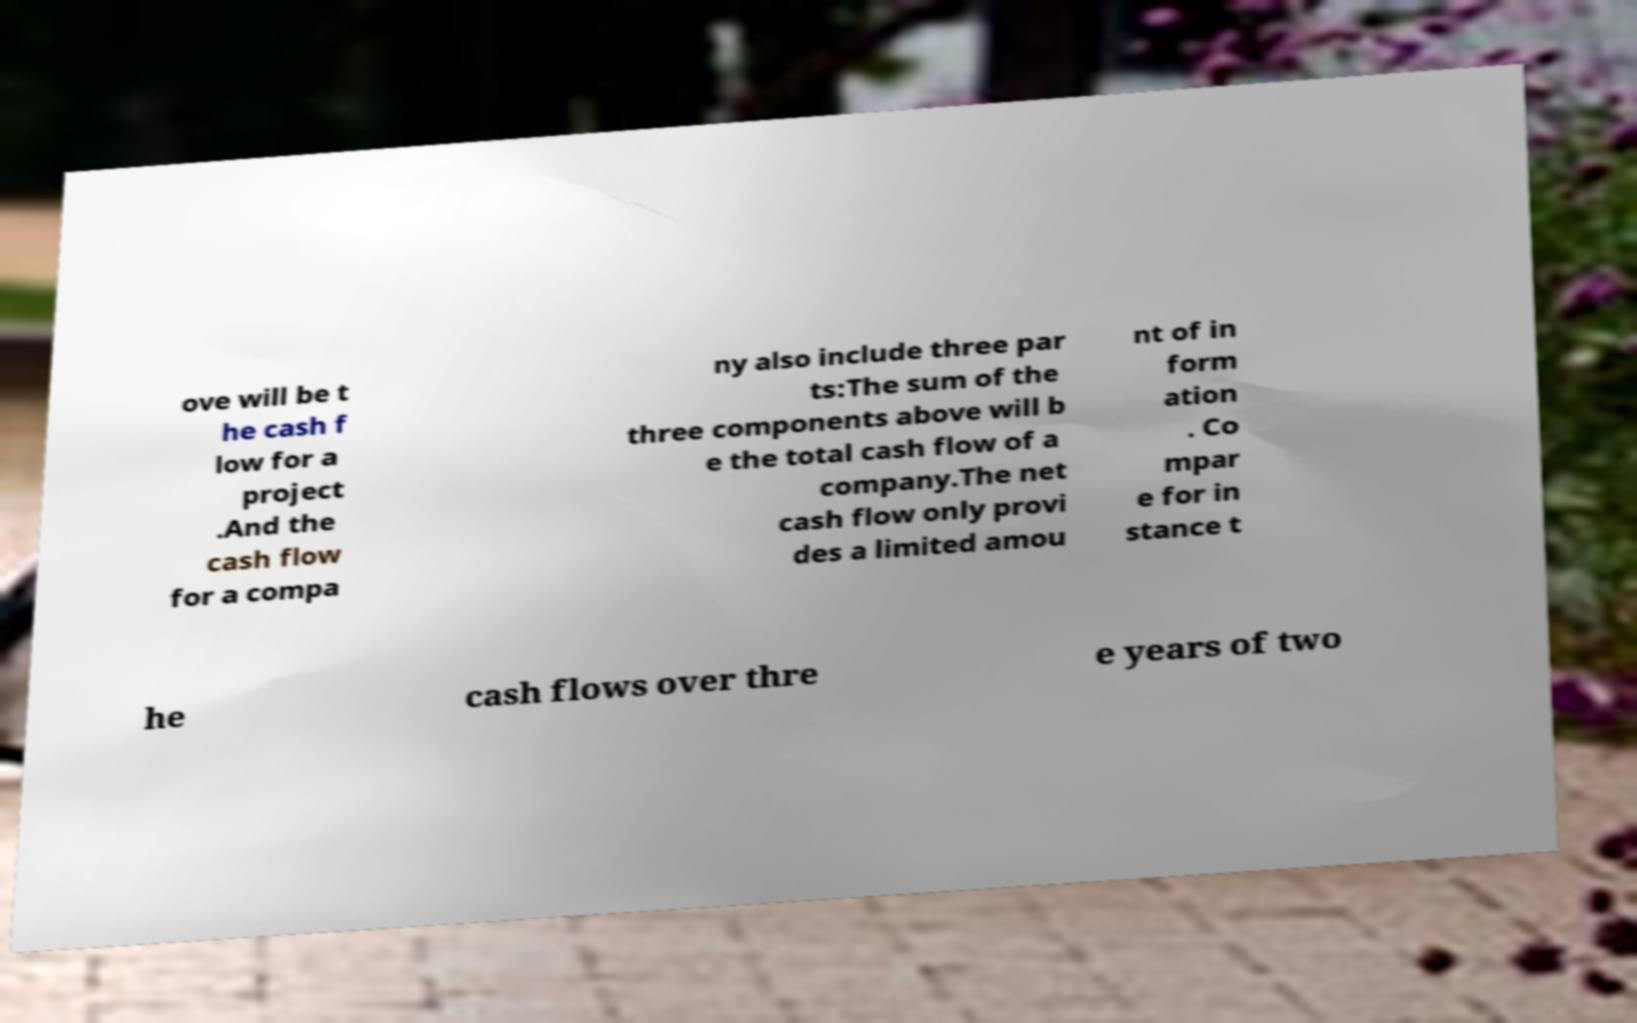Could you assist in decoding the text presented in this image and type it out clearly? ove will be t he cash f low for a project .And the cash flow for a compa ny also include three par ts:The sum of the three components above will b e the total cash flow of a company.The net cash flow only provi des a limited amou nt of in form ation . Co mpar e for in stance t he cash flows over thre e years of two 